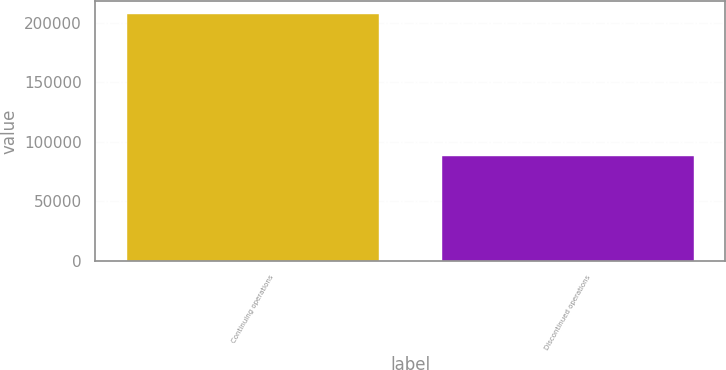Convert chart. <chart><loc_0><loc_0><loc_500><loc_500><bar_chart><fcel>Continuing operations<fcel>Discontinued operations<nl><fcel>207510<fcel>88216<nl></chart> 